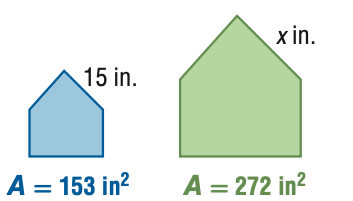Answer the mathemtical geometry problem and directly provide the correct option letter.
Question: For the pair of similar figures, use the given areas to find the scale factor from the blue to the green figure.
Choices: A: \frac { 9 } { 16 } B: \frac { 3 } { 4 } C: \frac { 4 } { 3 } D: \frac { 16 } { 9 } B 